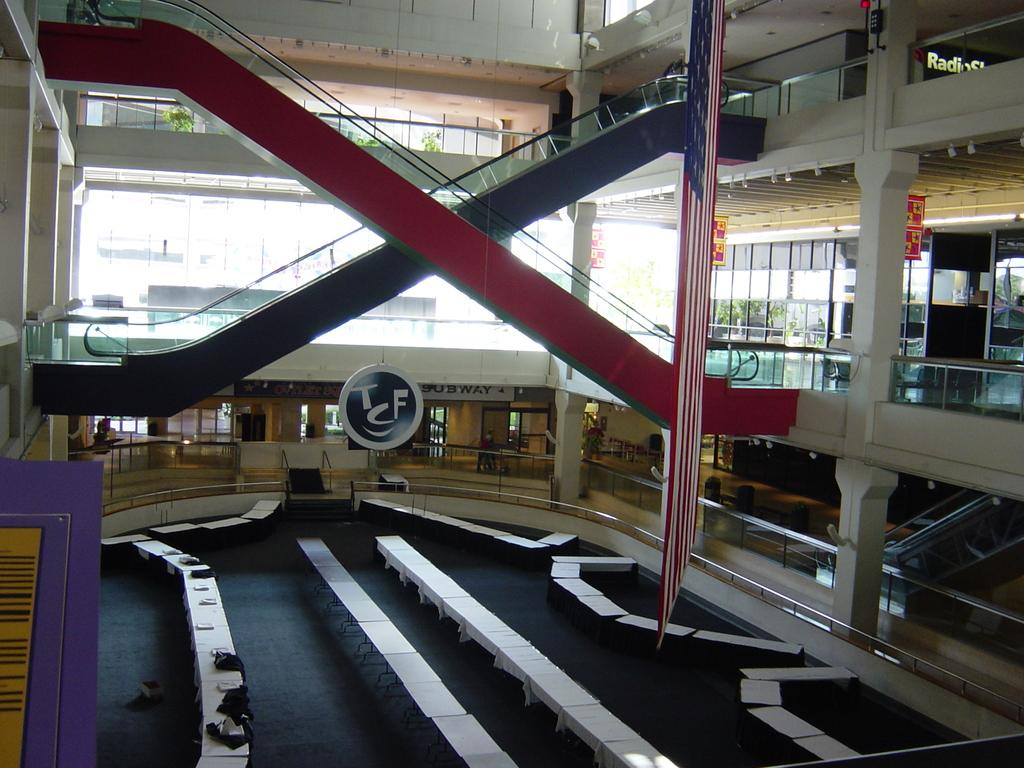What type of furniture is present in the image? There are white tables in the image. What else can be seen on the tables? There are boards on the tables. What kind of natural elements are in the image? There are plants in the image. What can be read or seen in terms of written content? There is text visible in the image. Can you see a swing in the image? No, there is no swing present in the image. What emotion is being expressed by the plants in the image? Plants do not express emotions, so this question cannot be answered. 